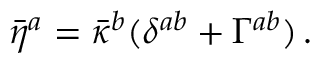<formula> <loc_0><loc_0><loc_500><loc_500>\bar { \eta } ^ { a } = \bar { \kappa } ^ { b } ( \delta ^ { a b } + \Gamma ^ { a b } ) \, .</formula> 